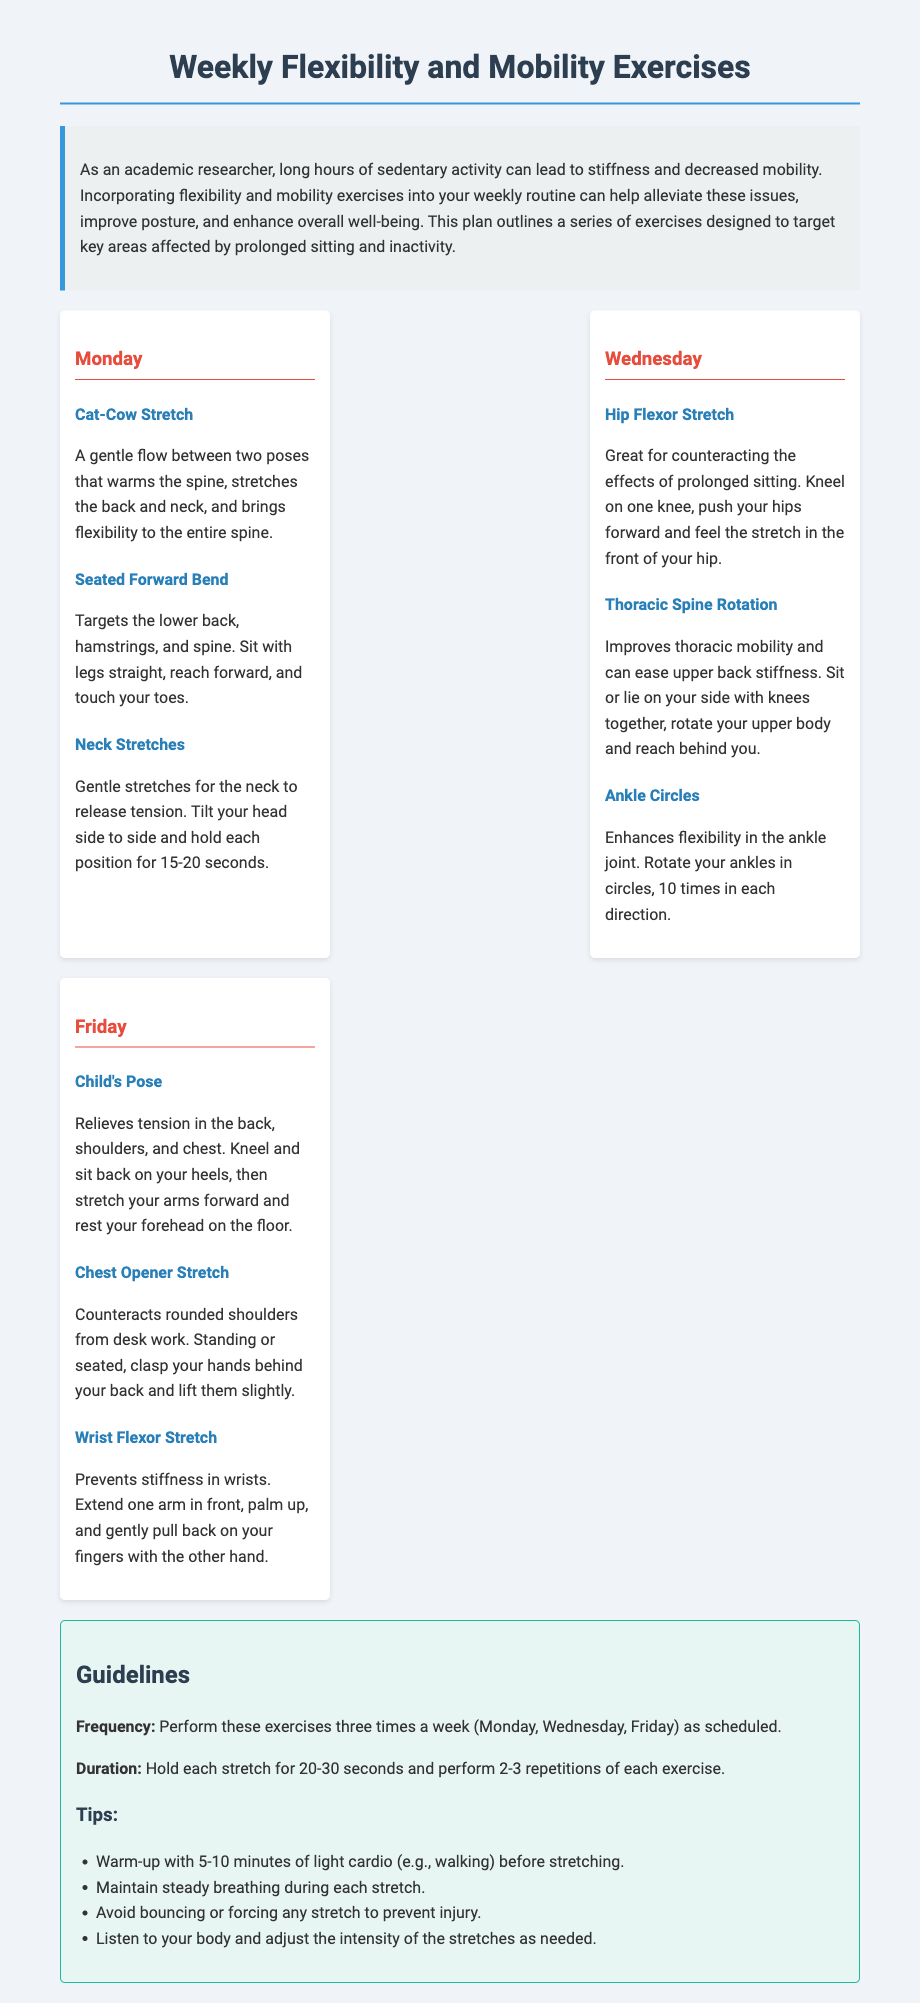What is the title of the document? The title is explicitly stated in the document's heading.
Answer: Weekly Flexibility and Mobility Exercises What day is the Hip Flexor Stretch scheduled? The day is found in the section outlining the exercises listed for each day of the week.
Answer: Wednesday How many times a week should the exercises be performed? The frequency of exercise is mentioned in the guidelines section of the document.
Answer: Three What is the suggested duration for holding each stretch? This duration is specified in the guidelines section.
Answer: 20-30 seconds What is the primary benefit of the Cat-Cow Stretch? This benefit is described in the exercise details under the Cat-Cow Stretch.
Answer: Warms the spine What should you do before starting the stretches? This recommendation is provided in the tips under the guidelines section.
Answer: Warm-up What target area does the Seated Forward Bend focus on? The target area is mentioned in the exercise description of the Seated Forward Bend.
Answer: Lower back, hamstrings, spine What exercise is suggested for counteracting rounded shoulders? The exercise related to this condition is explicitly listed in the document as a solution.
Answer: Chest Opener Stretch How many repetitions of each exercise should be performed? The number of repetitions is specified in the guidelines section of the document.
Answer: 2-3 repetitions 